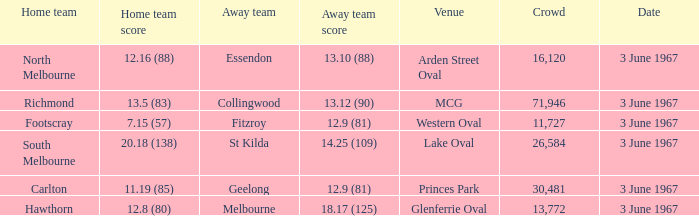Where did Geelong play as the away team? Princes Park. 